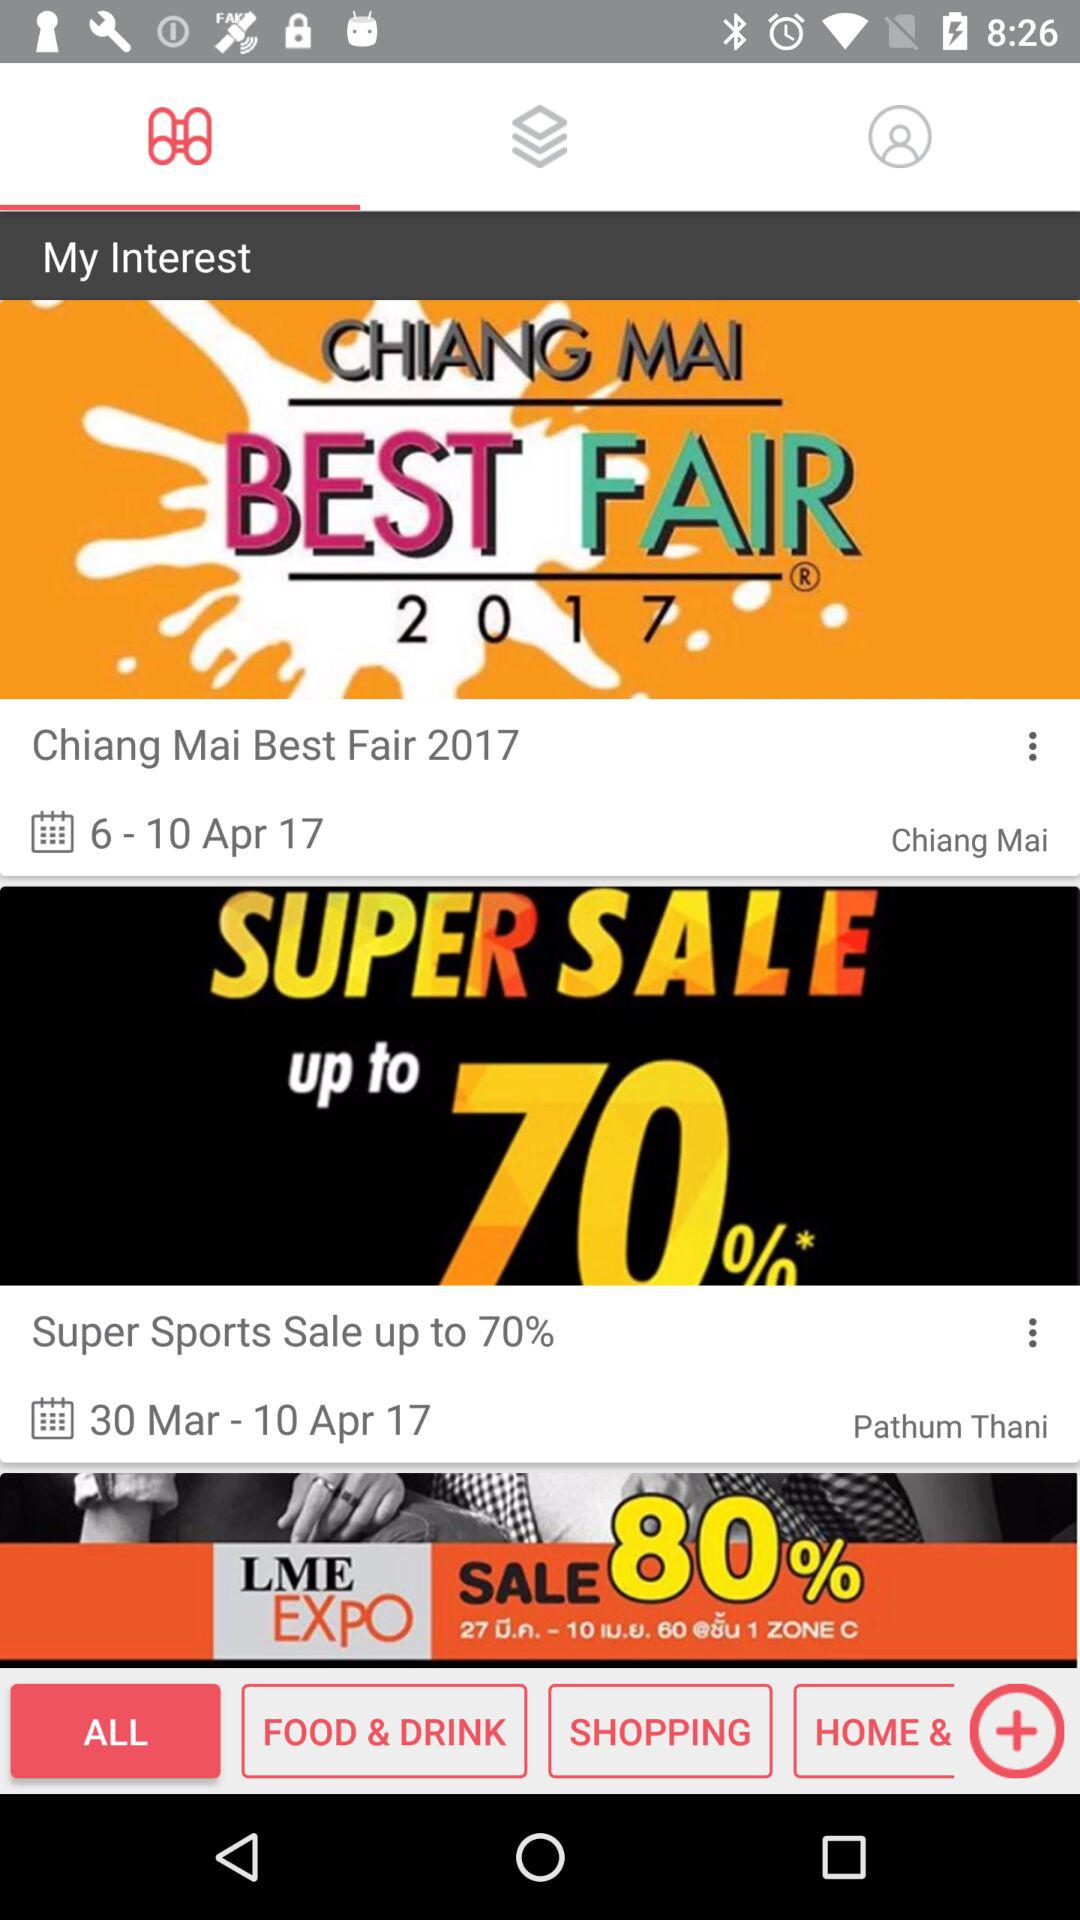How many days are in the event for the first item?
Answer the question using a single word or phrase. 4 